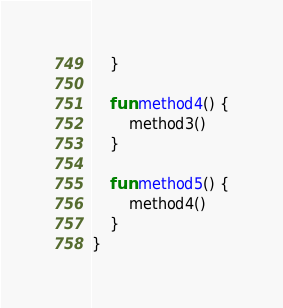<code> <loc_0><loc_0><loc_500><loc_500><_Kotlin_>    }

    fun method4() {
        method3()
    }

    fun method5() {
        method4()
    }
}
</code> 